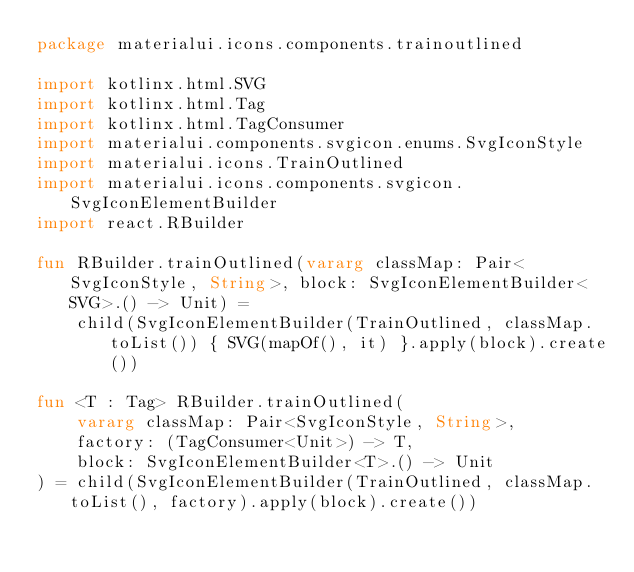<code> <loc_0><loc_0><loc_500><loc_500><_Kotlin_>package materialui.icons.components.trainoutlined

import kotlinx.html.SVG
import kotlinx.html.Tag
import kotlinx.html.TagConsumer
import materialui.components.svgicon.enums.SvgIconStyle
import materialui.icons.TrainOutlined
import materialui.icons.components.svgicon.SvgIconElementBuilder
import react.RBuilder

fun RBuilder.trainOutlined(vararg classMap: Pair<SvgIconStyle, String>, block: SvgIconElementBuilder<SVG>.() -> Unit) =
    child(SvgIconElementBuilder(TrainOutlined, classMap.toList()) { SVG(mapOf(), it) }.apply(block).create())

fun <T : Tag> RBuilder.trainOutlined(
    vararg classMap: Pair<SvgIconStyle, String>,
    factory: (TagConsumer<Unit>) -> T,
    block: SvgIconElementBuilder<T>.() -> Unit
) = child(SvgIconElementBuilder(TrainOutlined, classMap.toList(), factory).apply(block).create())
</code> 